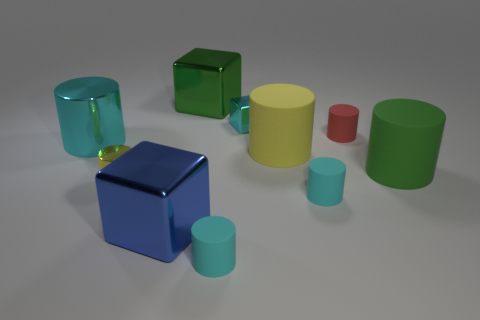Subtract all blue metallic cubes. How many cubes are left? 2 Subtract all yellow balls. How many yellow cylinders are left? 2 Subtract all cyan cylinders. How many cylinders are left? 4 Subtract all cubes. How many objects are left? 7 Subtract all blue cylinders. Subtract all blue spheres. How many cylinders are left? 7 Add 6 cyan blocks. How many cyan blocks exist? 7 Subtract 0 red cubes. How many objects are left? 10 Subtract all big yellow rubber things. Subtract all rubber cylinders. How many objects are left? 4 Add 3 cyan things. How many cyan things are left? 7 